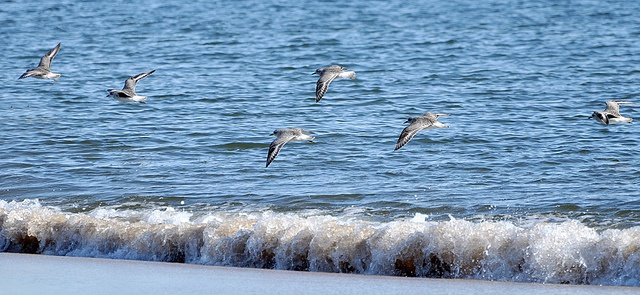Describe the objects in this image and their specific colors. I can see bird in gray, darkgray, lightgray, and lightblue tones, bird in gray, darkgray, lightgray, and black tones, bird in gray, darkgray, and lightgray tones, bird in gray, darkgray, lightgray, and black tones, and bird in gray, darkgray, lightgray, and black tones in this image. 